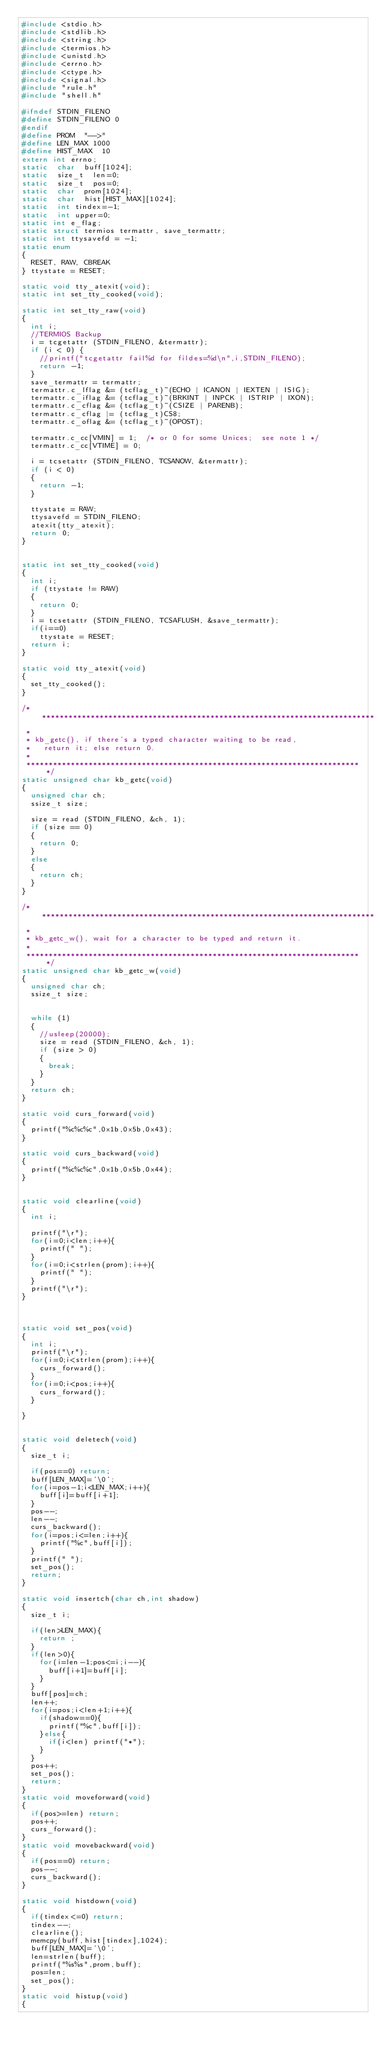<code> <loc_0><loc_0><loc_500><loc_500><_C_>#include <stdio.h>
#include <stdlib.h>
#include <string.h>
#include <termios.h>
#include <unistd.h>
#include <errno.h>
#include <ctype.h>
#include <signal.h>
#include "rule.h"
#include "shell.h"

#ifndef STDIN_FILENO
#define STDIN_FILENO 0
#endif
#define	PROM	"-->"
#define	LEN_MAX	1000
#define	HIST_MAX	10
extern int errno; 
static 	char	buff[1024];
static	size_t	len=0;
static	size_t	pos=0;
static	char	prom[1024];
static	char	hist[HIST_MAX][1024];
static	int	tindex=-1;
static	int	upper=0;
static int e_flag;
static struct termios termattr, save_termattr;
static int ttysavefd = -1;
static enum 
{ 
	RESET, RAW, CBREAK 
} ttystate = RESET;

static void tty_atexit(void);
static int set_tty_cooked(void);

static int set_tty_raw(void) 
{
	int i;
	//TERMIOS Backup
	i = tcgetattr (STDIN_FILENO, &termattr);
	if (i < 0) {
		//printf("tcgetattr fail%d for fildes=%d\n",i,STDIN_FILENO); 
		return -1;
	}
	save_termattr = termattr;
	termattr.c_lflag &= (tcflag_t)~(ECHO | ICANON | IEXTEN | ISIG);
	termattr.c_iflag &= (tcflag_t)~(BRKINT | INPCK | ISTRIP | IXON);
	termattr.c_cflag &= (tcflag_t)~(CSIZE | PARENB);
	termattr.c_cflag |= (tcflag_t)CS8;
	termattr.c_oflag &= (tcflag_t)~(OPOST);
	 
	termattr.c_cc[VMIN] = 1;	/* or 0 for some Unices;	see note 1 */
	termattr.c_cc[VTIME] = 0;

	i = tcsetattr (STDIN_FILENO, TCSANOW, &termattr);
	if (i < 0) 
	{
		return -1;
	}
	 
	ttystate = RAW;
	ttysavefd = STDIN_FILENO;
	atexit(tty_atexit);
	return 0;
}


static int set_tty_cooked(void) 
{
	int i;
	if (ttystate != RAW) 
	{
		return 0;
	}
	i = tcsetattr (STDIN_FILENO, TCSAFLUSH, &save_termattr);
	if(i==0)
		ttystate = RESET;
	return i;
}

static void tty_atexit(void)
{
	set_tty_cooked();
}
	
/* ***************************************************************************
 *
 * kb_getc(), if there's a typed character waiting to be read,
 *	 return it; else return 0.
 *
 *************************************************************************** */
static unsigned char kb_getc(void) 
{
	unsigned char ch;
	ssize_t size;

	size = read (STDIN_FILENO, &ch, 1);
	if (size == 0)
	{
		return 0;
	}
	else
	{
		return ch;
	}
}

/* ***************************************************************************
 *
 * kb_getc_w(), wait for a character to be typed and return it.
 *
 *************************************************************************** */
static unsigned char kb_getc_w(void) 
{
	unsigned char ch;
	ssize_t size;


	while (1)
	{
		//usleep(20000);
		size = read (STDIN_FILENO, &ch, 1);
		if (size > 0)
		{
			break;
		}
	}
	return ch;
}

static void curs_forward(void)
{
	printf("%c%c%c",0x1b,0x5b,0x43);
}

static void curs_backward(void)
{
	printf("%c%c%c",0x1b,0x5b,0x44);
}


static void clearline(void)
{
	int i;

	printf("\r");
	for(i=0;i<len;i++){
		printf(" ");
	}
	for(i=0;i<strlen(prom);i++){
		printf(" ");
	}
	printf("\r");
}



static void set_pos(void)
{
	int i;
	printf("\r");
	for(i=0;i<strlen(prom);i++){
		curs_forward();
	}
	for(i=0;i<pos;i++){
		curs_forward();
	}

}


static void deletech(void)
{
	size_t i;

	if(pos==0) return;
	buff[LEN_MAX]='\0';
	for(i=pos-1;i<LEN_MAX;i++){
		buff[i]=buff[i+1];
	}
	pos--;
	len--;
	curs_backward();
	for(i=pos;i<=len;i++){
		printf("%c",buff[i]);
	}
	printf(" ");
	set_pos();
	return;
}

static void insertch(char ch,int shadow)
{
	size_t i;

	if(len>LEN_MAX){
		return ;
	}
	if(len>0){
		for(i=len-1;pos<=i;i--){
			buff[i+1]=buff[i];
		}
	}
	buff[pos]=ch;
	len++;
	for(i=pos;i<len+1;i++){
		if(shadow==0){
			printf("%c",buff[i]);
		}else{
			if(i<len) printf("*");
		}
	}
	pos++;
	set_pos();
	return;
}
static void moveforward(void)
{
	if(pos>=len) return;
	pos++;
	curs_forward();
}
static void movebackward(void)
{
	if(pos==0) return;
	pos--;
	curs_backward();
}

static void histdown(void)
{
	if(tindex<=0) return;
	tindex--;
	clearline();
	memcpy(buff,hist[tindex],1024);
	buff[LEN_MAX]='\0';
	len=strlen(buff);
	printf("%s%s",prom,buff);
	pos=len;
	set_pos();
}
static void histup(void)
{</code> 